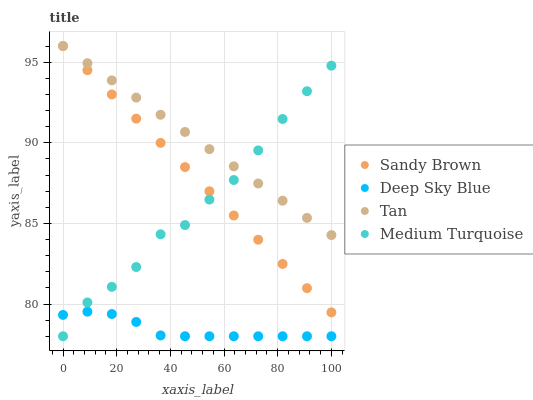Does Deep Sky Blue have the minimum area under the curve?
Answer yes or no. Yes. Does Tan have the maximum area under the curve?
Answer yes or no. Yes. Does Sandy Brown have the minimum area under the curve?
Answer yes or no. No. Does Sandy Brown have the maximum area under the curve?
Answer yes or no. No. Is Sandy Brown the smoothest?
Answer yes or no. Yes. Is Medium Turquoise the roughest?
Answer yes or no. Yes. Is Medium Turquoise the smoothest?
Answer yes or no. No. Is Sandy Brown the roughest?
Answer yes or no. No. Does Medium Turquoise have the lowest value?
Answer yes or no. Yes. Does Sandy Brown have the lowest value?
Answer yes or no. No. Does Sandy Brown have the highest value?
Answer yes or no. Yes. Does Medium Turquoise have the highest value?
Answer yes or no. No. Is Deep Sky Blue less than Tan?
Answer yes or no. Yes. Is Sandy Brown greater than Deep Sky Blue?
Answer yes or no. Yes. Does Medium Turquoise intersect Deep Sky Blue?
Answer yes or no. Yes. Is Medium Turquoise less than Deep Sky Blue?
Answer yes or no. No. Is Medium Turquoise greater than Deep Sky Blue?
Answer yes or no. No. Does Deep Sky Blue intersect Tan?
Answer yes or no. No. 